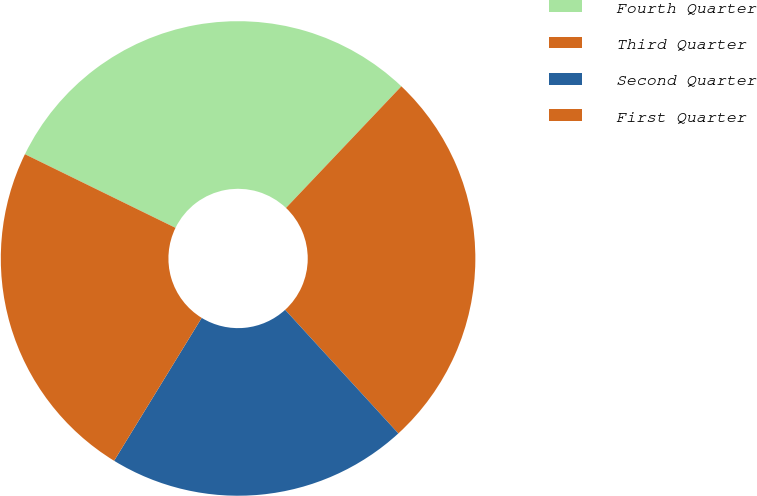Convert chart. <chart><loc_0><loc_0><loc_500><loc_500><pie_chart><fcel>Fourth Quarter<fcel>Third Quarter<fcel>Second Quarter<fcel>First Quarter<nl><fcel>29.84%<fcel>26.12%<fcel>20.55%<fcel>23.49%<nl></chart> 